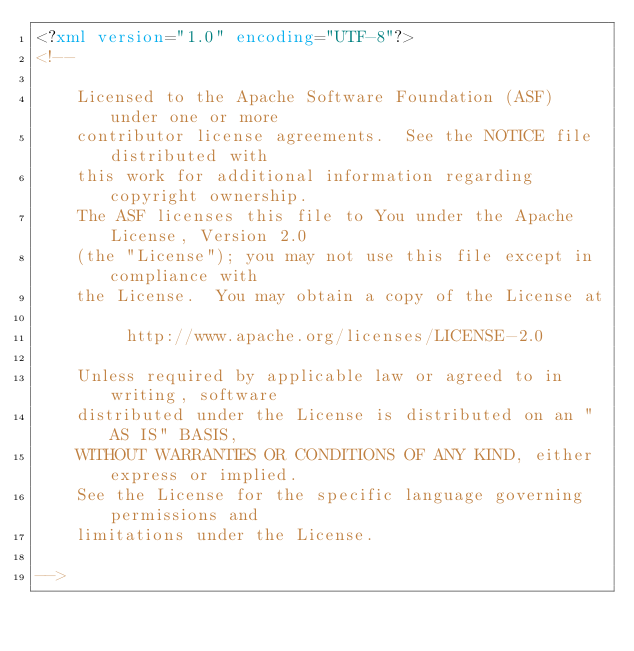Convert code to text. <code><loc_0><loc_0><loc_500><loc_500><_XML_><?xml version="1.0" encoding="UTF-8"?>
<!--

    Licensed to the Apache Software Foundation (ASF) under one or more
    contributor license agreements.  See the NOTICE file distributed with
    this work for additional information regarding copyright ownership.
    The ASF licenses this file to You under the Apache License, Version 2.0
    (the "License"); you may not use this file except in compliance with
    the License.  You may obtain a copy of the License at

         http://www.apache.org/licenses/LICENSE-2.0

    Unless required by applicable law or agreed to in writing, software
    distributed under the License is distributed on an "AS IS" BASIS,
    WITHOUT WARRANTIES OR CONDITIONS OF ANY KIND, either express or implied.
    See the License for the specific language governing permissions and
    limitations under the License.

--></code> 